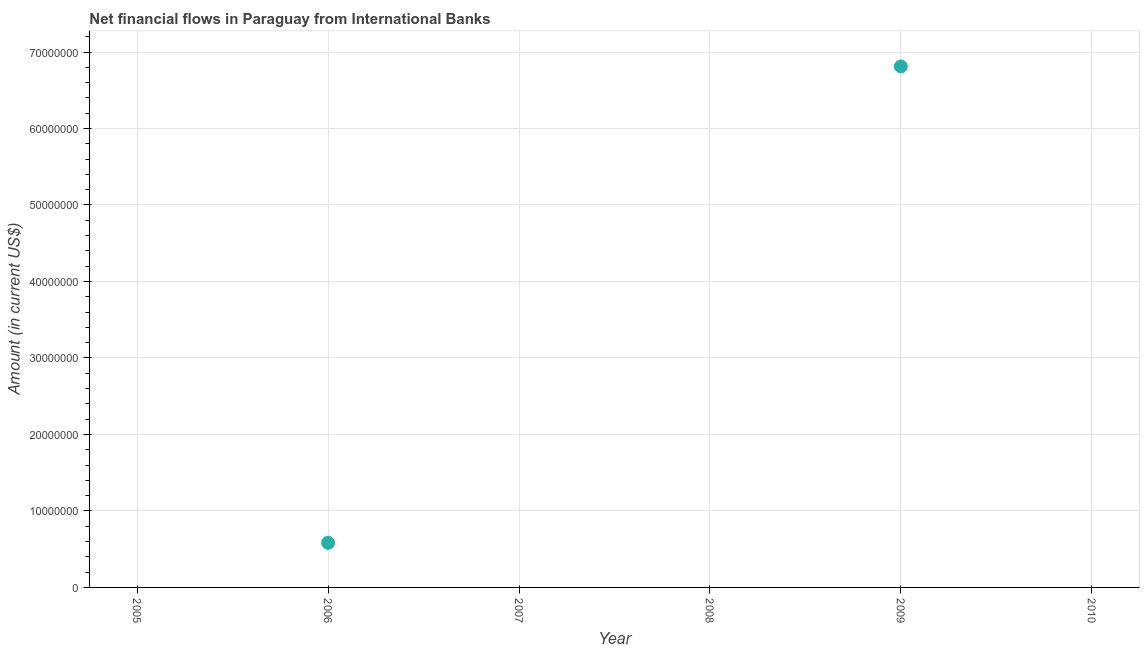What is the net financial flows from ibrd in 2009?
Provide a short and direct response. 6.81e+07. Across all years, what is the maximum net financial flows from ibrd?
Ensure brevity in your answer.  6.81e+07. In which year was the net financial flows from ibrd maximum?
Your response must be concise. 2009. What is the sum of the net financial flows from ibrd?
Provide a short and direct response. 7.39e+07. What is the average net financial flows from ibrd per year?
Provide a short and direct response. 1.23e+07. What is the median net financial flows from ibrd?
Offer a terse response. 0. In how many years, is the net financial flows from ibrd greater than 70000000 US$?
Your response must be concise. 0. What is the difference between the highest and the lowest net financial flows from ibrd?
Your response must be concise. 6.81e+07. How many years are there in the graph?
Your answer should be very brief. 6. Are the values on the major ticks of Y-axis written in scientific E-notation?
Give a very brief answer. No. Does the graph contain grids?
Offer a terse response. Yes. What is the title of the graph?
Provide a succinct answer. Net financial flows in Paraguay from International Banks. What is the label or title of the Y-axis?
Offer a very short reply. Amount (in current US$). What is the Amount (in current US$) in 2005?
Offer a very short reply. 0. What is the Amount (in current US$) in 2006?
Offer a very short reply. 5.84e+06. What is the Amount (in current US$) in 2007?
Keep it short and to the point. 0. What is the Amount (in current US$) in 2009?
Offer a terse response. 6.81e+07. What is the difference between the Amount (in current US$) in 2006 and 2009?
Your response must be concise. -6.23e+07. What is the ratio of the Amount (in current US$) in 2006 to that in 2009?
Provide a short and direct response. 0.09. 